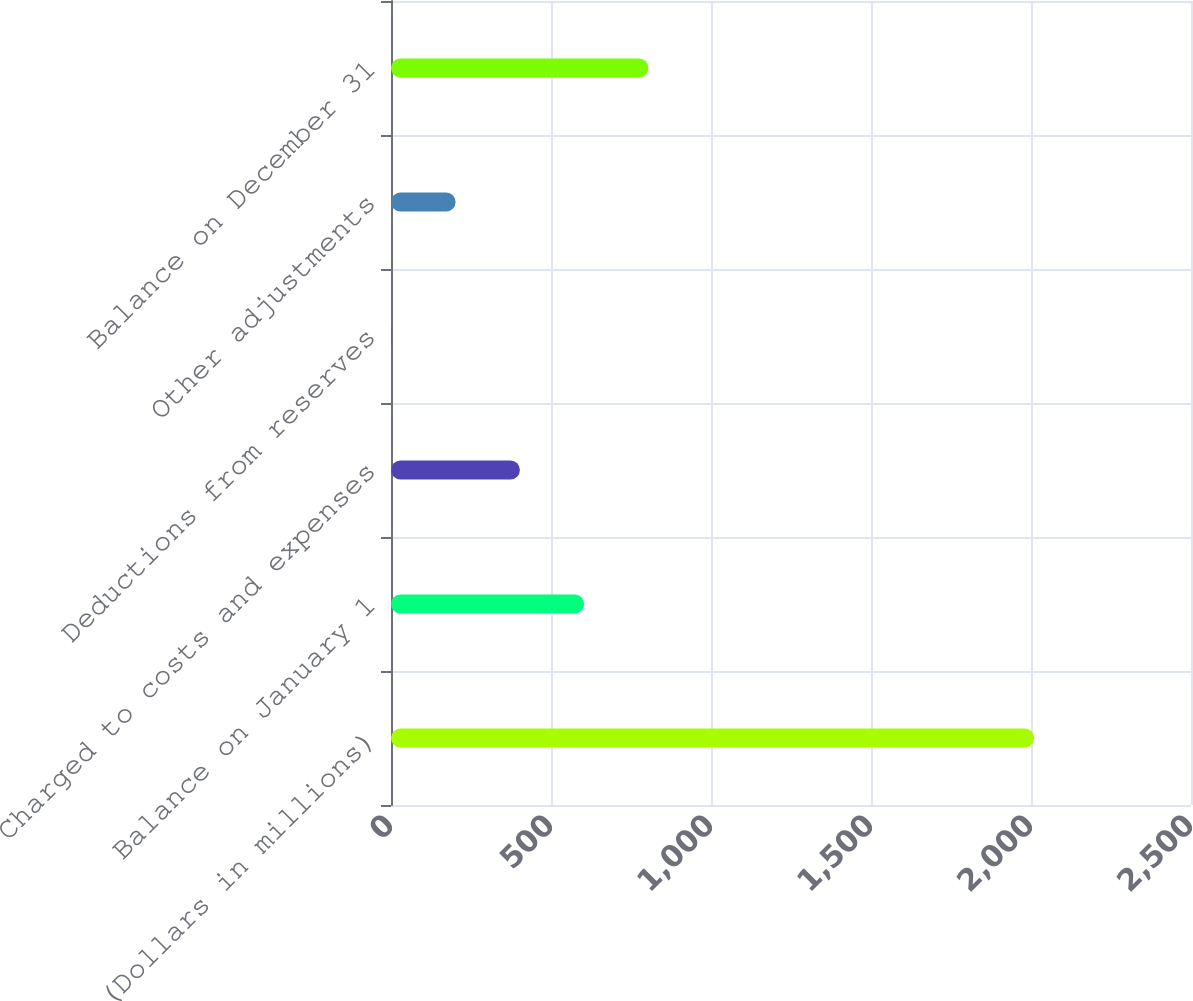<chart> <loc_0><loc_0><loc_500><loc_500><bar_chart><fcel>(Dollars in millions)<fcel>Balance on January 1<fcel>Charged to costs and expenses<fcel>Deductions from reserves<fcel>Other adjustments<fcel>Balance on December 31<nl><fcel>2010<fcel>603.7<fcel>402.8<fcel>1<fcel>201.9<fcel>804.6<nl></chart> 